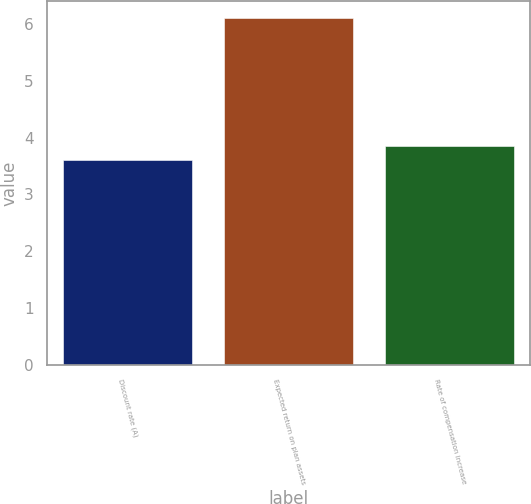Convert chart. <chart><loc_0><loc_0><loc_500><loc_500><bar_chart><fcel>Discount rate (A)<fcel>Expected return on plan assets<fcel>Rate of compensation increase<nl><fcel>3.6<fcel>6.1<fcel>3.85<nl></chart> 